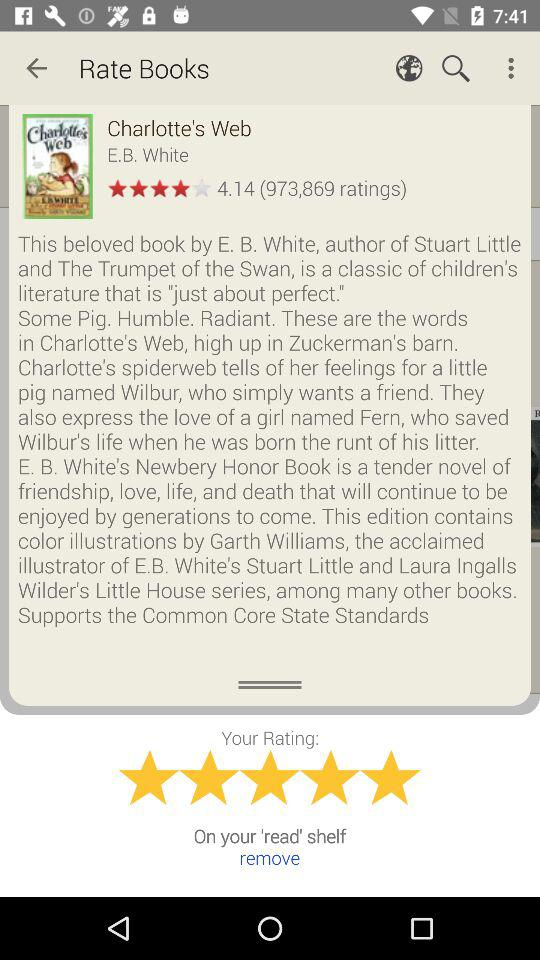What is the name of the book? The name of the book is "Charlotte's Web". 